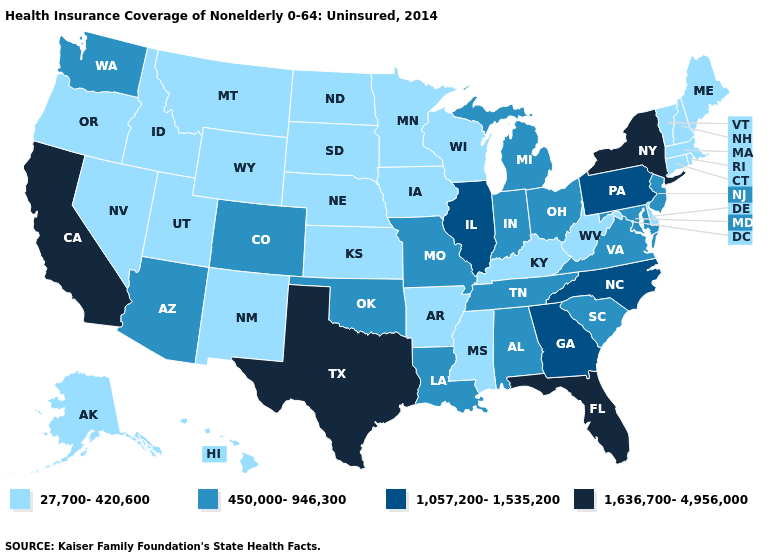What is the value of Illinois?
Concise answer only. 1,057,200-1,535,200. Name the states that have a value in the range 27,700-420,600?
Quick response, please. Alaska, Arkansas, Connecticut, Delaware, Hawaii, Idaho, Iowa, Kansas, Kentucky, Maine, Massachusetts, Minnesota, Mississippi, Montana, Nebraska, Nevada, New Hampshire, New Mexico, North Dakota, Oregon, Rhode Island, South Dakota, Utah, Vermont, West Virginia, Wisconsin, Wyoming. Which states have the lowest value in the South?
Quick response, please. Arkansas, Delaware, Kentucky, Mississippi, West Virginia. Does the first symbol in the legend represent the smallest category?
Answer briefly. Yes. What is the lowest value in the USA?
Short answer required. 27,700-420,600. Name the states that have a value in the range 1,636,700-4,956,000?
Keep it brief. California, Florida, New York, Texas. What is the highest value in states that border Kentucky?
Give a very brief answer. 1,057,200-1,535,200. Among the states that border California , which have the lowest value?
Short answer required. Nevada, Oregon. What is the highest value in states that border Wyoming?
Keep it brief. 450,000-946,300. Name the states that have a value in the range 1,057,200-1,535,200?
Answer briefly. Georgia, Illinois, North Carolina, Pennsylvania. What is the value of Massachusetts?
Quick response, please. 27,700-420,600. What is the highest value in the MidWest ?
Concise answer only. 1,057,200-1,535,200. Name the states that have a value in the range 27,700-420,600?
Concise answer only. Alaska, Arkansas, Connecticut, Delaware, Hawaii, Idaho, Iowa, Kansas, Kentucky, Maine, Massachusetts, Minnesota, Mississippi, Montana, Nebraska, Nevada, New Hampshire, New Mexico, North Dakota, Oregon, Rhode Island, South Dakota, Utah, Vermont, West Virginia, Wisconsin, Wyoming. What is the value of Pennsylvania?
Be succinct. 1,057,200-1,535,200. 